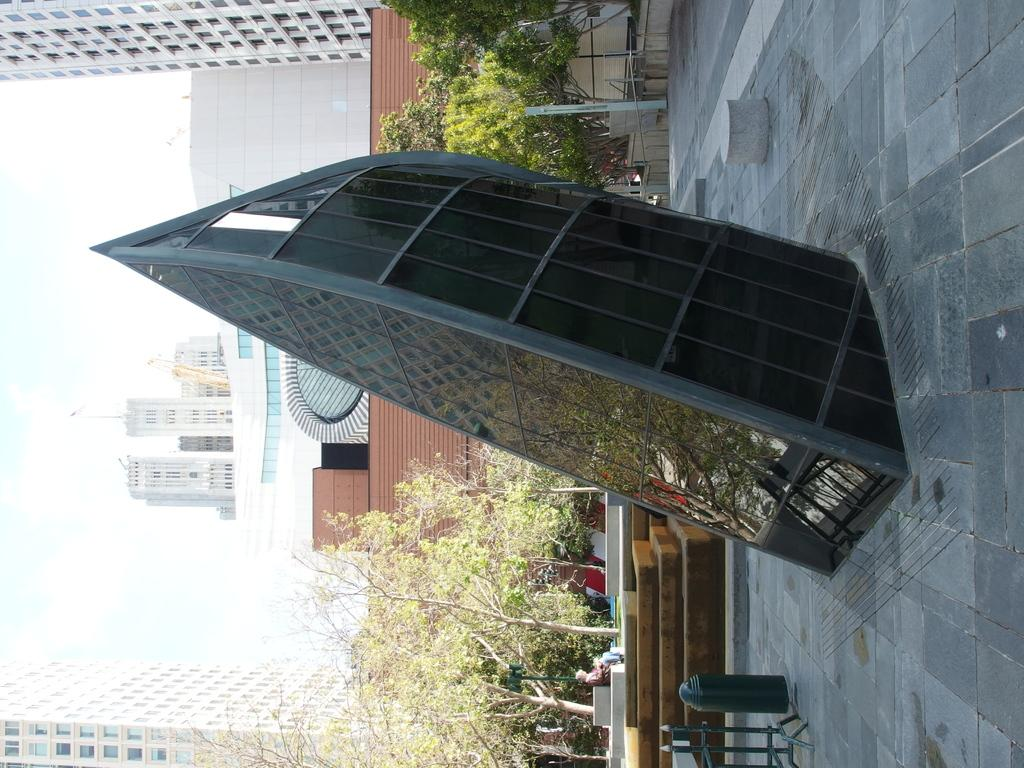What type of architectural structure is visible in the image? There is an architectural structure with glass in the image. What can be seen behind the structure? Trees are visible behind the structure. What is present in the background of the image? Poles and buildings are present in the background of the image. What objects are made of metal and located at the bottom of the image? Metal objects are present at the bottom of the image. What feature allows for movement within the structure? Stairs are visible in the image. How many eggs are visible on the bridge in the image? There is no bridge or eggs present in the image. What type of potato is being used to decorate the structure in the image? There are no potatoes present in the image. 